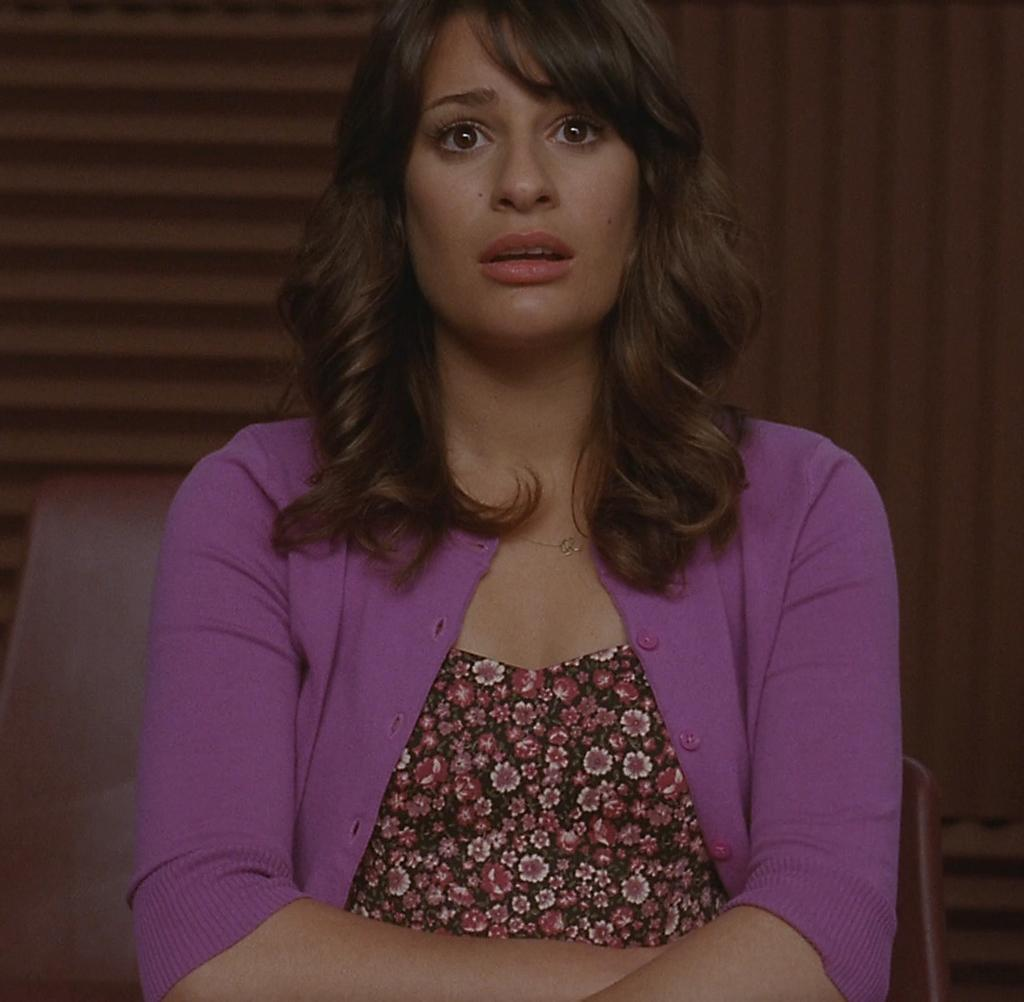Who is the main subject in the image? There is a girl in the image. What is the girl wearing? The girl is wearing a purple sweater. What is the girl doing in the image? The girl is sitting on a chair. What direction is the girl looking in? The girl is looking straight. How many apples can be seen on the chair the girl is sitting on? There are no apples present in the image, so it is not possible to determine how many apples might be on the chair. 